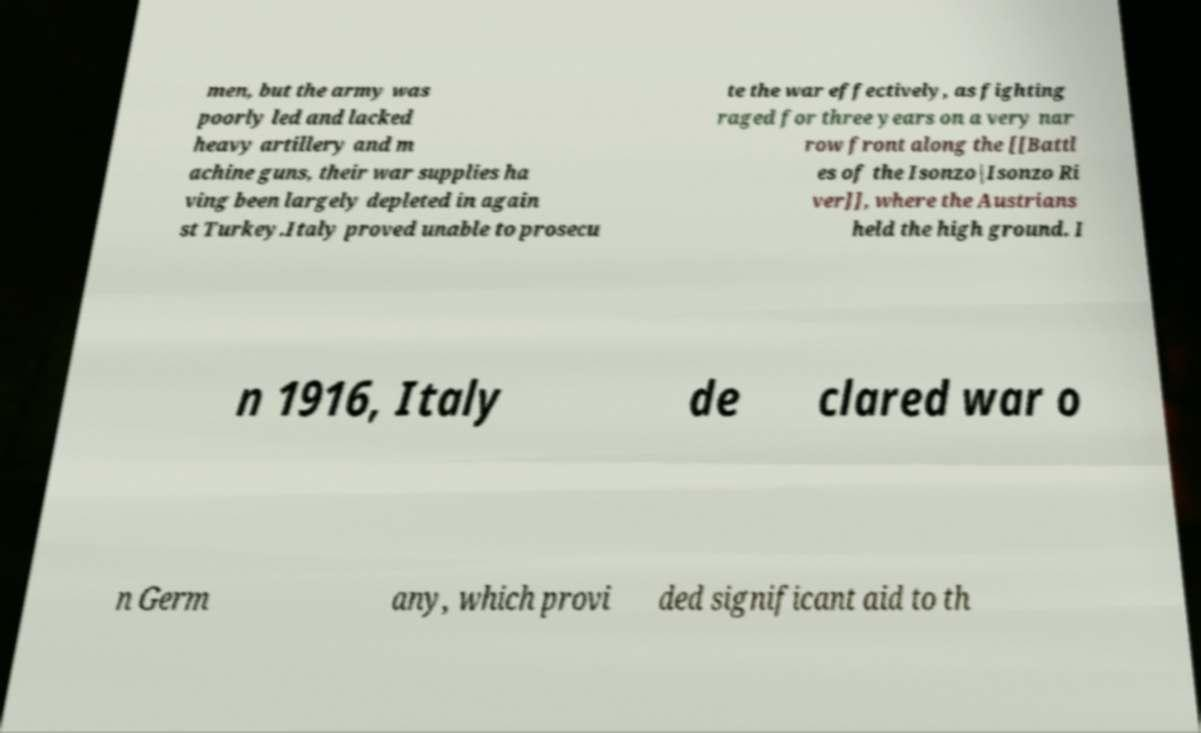Please identify and transcribe the text found in this image. men, but the army was poorly led and lacked heavy artillery and m achine guns, their war supplies ha ving been largely depleted in again st Turkey.Italy proved unable to prosecu te the war effectively, as fighting raged for three years on a very nar row front along the [[Battl es of the Isonzo|Isonzo Ri ver]], where the Austrians held the high ground. I n 1916, Italy de clared war o n Germ any, which provi ded significant aid to th 